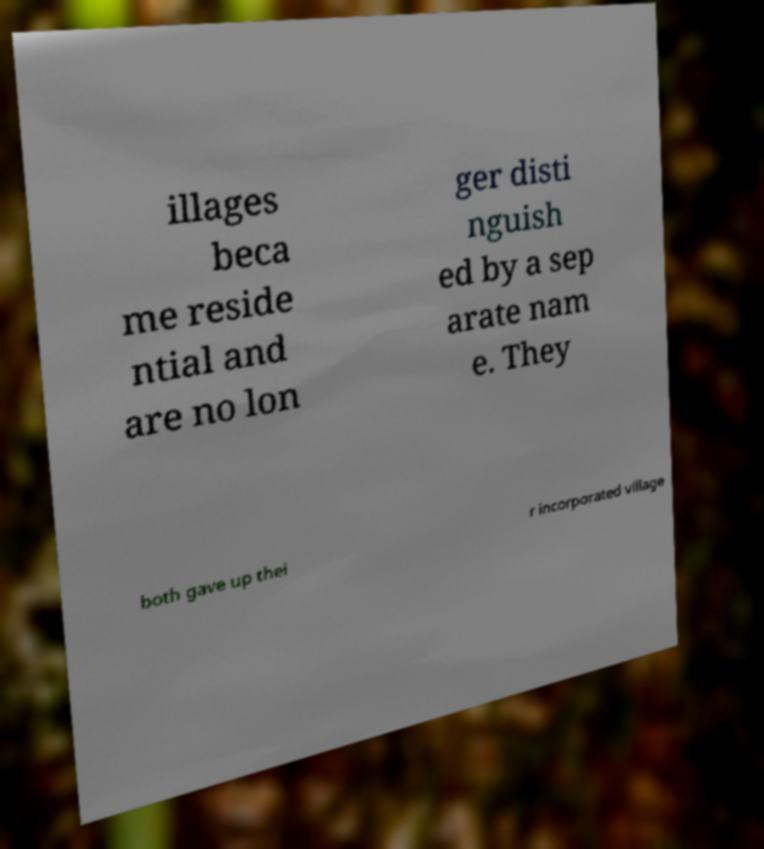There's text embedded in this image that I need extracted. Can you transcribe it verbatim? illages beca me reside ntial and are no lon ger disti nguish ed by a sep arate nam e. They both gave up thei r incorporated village 